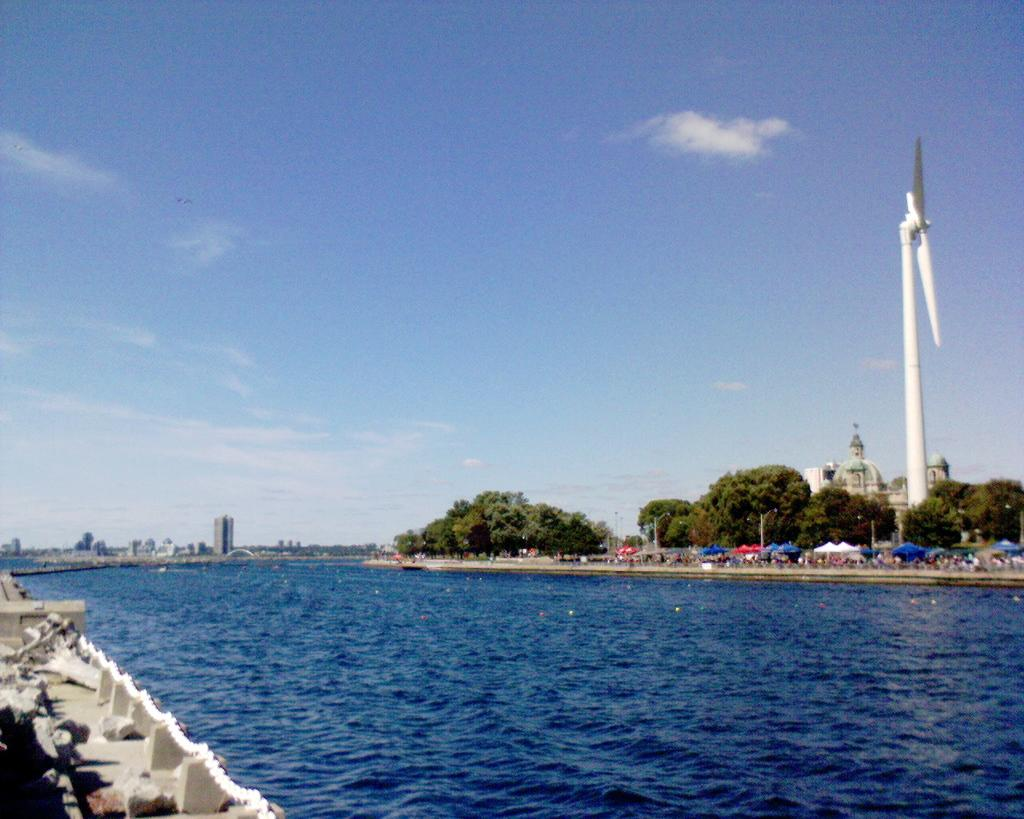What is the primary element visible in the image? There is water in the image. What can be seen in the background of the image? There are trees, a wind fan, tents, buildings, and the sky visible in the background of the image. What is the condition of the sky in the image? The sky is visible in the background of the image, and clouds are present. What type of pie is being served at the campsite in the image? There is no campsite or pie present in the image; it features water, trees, a wind fan, tents, buildings, and the sky. What is the name of the person standing near the water in the image? There is no person standing near the water in the image, so it is not possible to determine their name. 